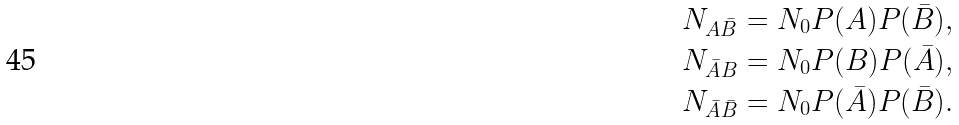Convert formula to latex. <formula><loc_0><loc_0><loc_500><loc_500>N _ { A \bar { B } } = N _ { 0 } P ( A ) P ( \bar { B } ) , \\ N _ { \bar { A } B } = N _ { 0 } P ( B ) P ( \bar { A } ) , \\ N _ { \bar { A } \bar { B } } = N _ { 0 } P ( \bar { A } ) P ( \bar { B } ) .</formula> 